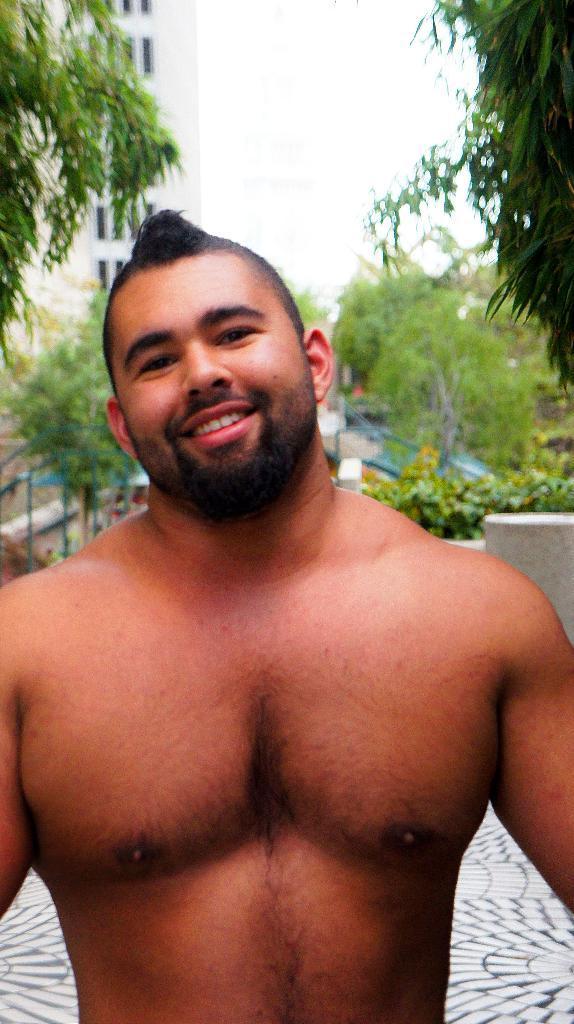In one or two sentences, can you explain what this image depicts? In the center of the image, we can see a man standing and in the background, there are trees and we can see a building and some railings and plants. At the top, there is sky and at the bottom, there is a road. 